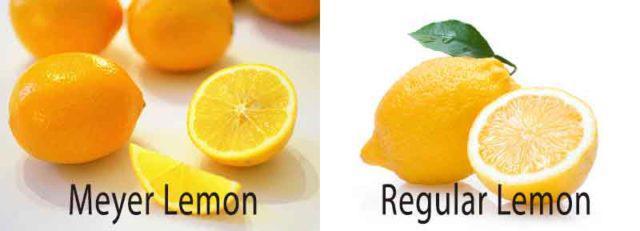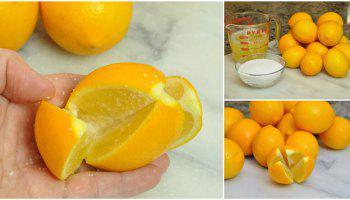The first image is the image on the left, the second image is the image on the right. For the images displayed, is the sentence "There are only two whole lemons in one of the images." factually correct? Answer yes or no. No. 